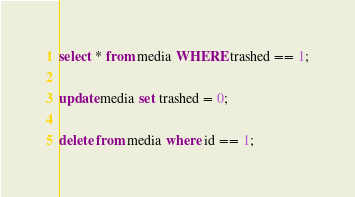<code> <loc_0><loc_0><loc_500><loc_500><_SQL_>select * from media WHERE trashed == 1;

update media set trashed = 0;

delete from media where id == 1;
</code> 